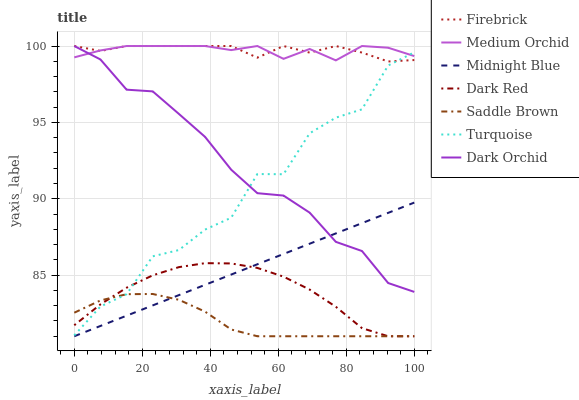Does Saddle Brown have the minimum area under the curve?
Answer yes or no. Yes. Does Medium Orchid have the maximum area under the curve?
Answer yes or no. Yes. Does Midnight Blue have the minimum area under the curve?
Answer yes or no. No. Does Midnight Blue have the maximum area under the curve?
Answer yes or no. No. Is Midnight Blue the smoothest?
Answer yes or no. Yes. Is Turquoise the roughest?
Answer yes or no. Yes. Is Dark Red the smoothest?
Answer yes or no. No. Is Dark Red the roughest?
Answer yes or no. No. Does Firebrick have the lowest value?
Answer yes or no. No. Does Midnight Blue have the highest value?
Answer yes or no. No. Is Midnight Blue less than Firebrick?
Answer yes or no. Yes. Is Turquoise greater than Midnight Blue?
Answer yes or no. Yes. Does Midnight Blue intersect Firebrick?
Answer yes or no. No. 